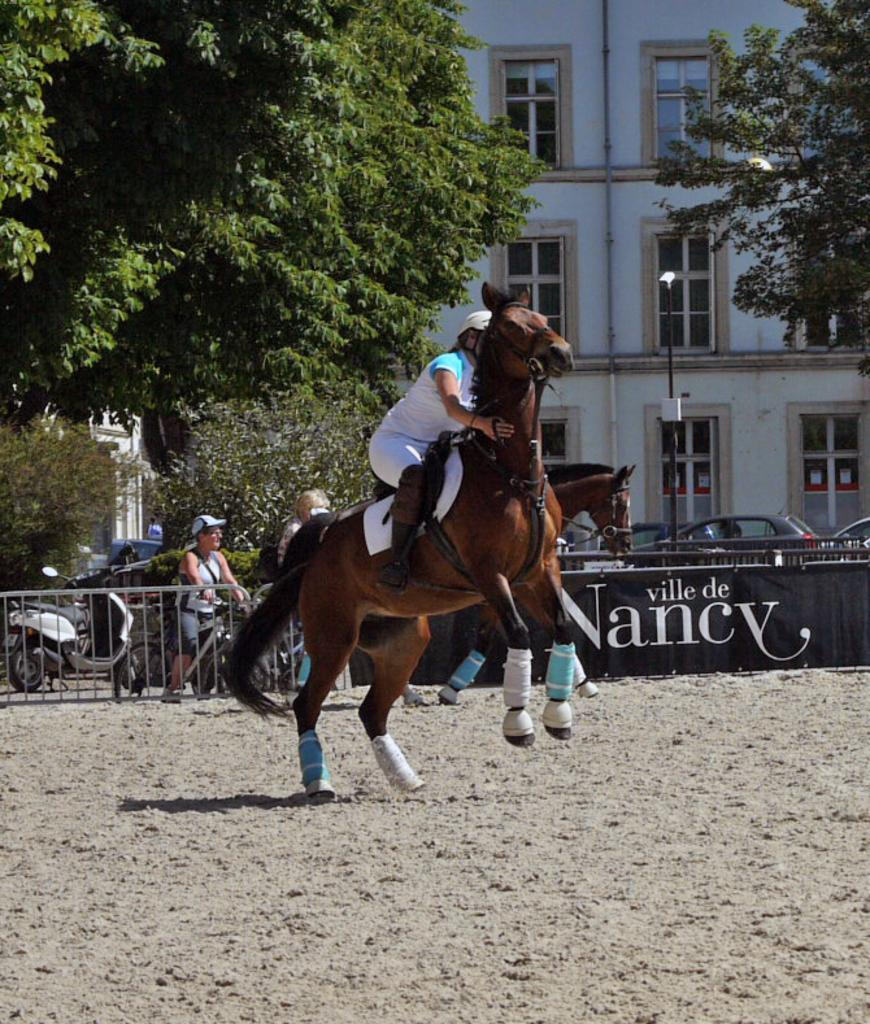What is the main subject of the image? There is a person riding a horse in the image. What can be seen in the background of the image? There is a building, a street light, vehicles, and trees in the background of the image. Can you see a bear interacting with the person riding the horse in the image? There is no bear present in the image. How does the wind affect the person riding the horse in the image? The image does not provide any information about the wind, so it cannot be determined how it affects the person riding the horse. 